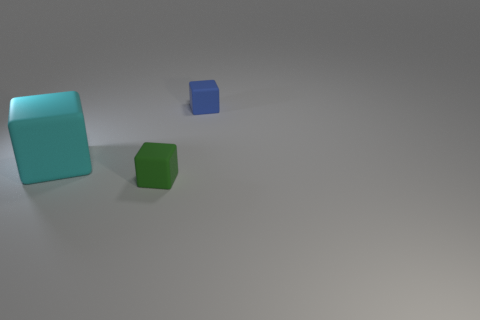Is there any other thing that is the same size as the cyan rubber block?
Provide a short and direct response. No. There is a big cyan matte thing; is it the same shape as the tiny matte thing to the left of the blue cube?
Your answer should be compact. Yes. What is the object that is both behind the small green rubber thing and in front of the blue thing made of?
Give a very brief answer. Rubber. There is another matte object that is the same size as the blue rubber thing; what is its color?
Provide a short and direct response. Green. Is the material of the small blue cube the same as the small block in front of the small blue matte object?
Your response must be concise. Yes. How many other objects are the same size as the cyan cube?
Give a very brief answer. 0. There is a small cube that is right of the small object on the left side of the blue rubber cube; is there a tiny blue matte cube that is to the left of it?
Provide a succinct answer. No. The blue matte thing has what size?
Make the answer very short. Small. What is the size of the rubber thing behind the cyan rubber object?
Your answer should be compact. Small. Does the matte block that is in front of the cyan block have the same size as the big cube?
Give a very brief answer. No. 